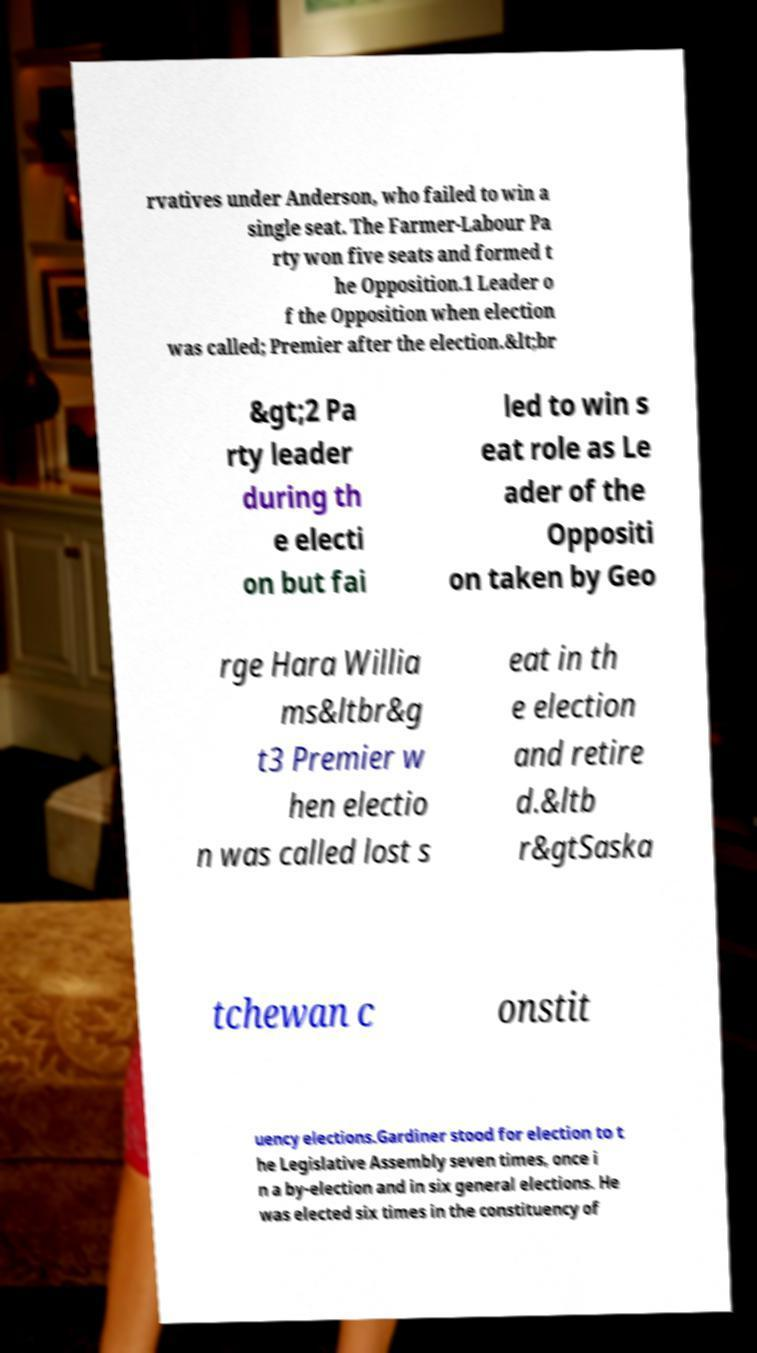Please read and relay the text visible in this image. What does it say? rvatives under Anderson, who failed to win a single seat. The Farmer-Labour Pa rty won five seats and formed t he Opposition.1 Leader o f the Opposition when election was called; Premier after the election.&lt;br &gt;2 Pa rty leader during th e electi on but fai led to win s eat role as Le ader of the Oppositi on taken by Geo rge Hara Willia ms&ltbr&g t3 Premier w hen electio n was called lost s eat in th e election and retire d.&ltb r&gtSaska tchewan c onstit uency elections.Gardiner stood for election to t he Legislative Assembly seven times, once i n a by-election and in six general elections. He was elected six times in the constituency of 